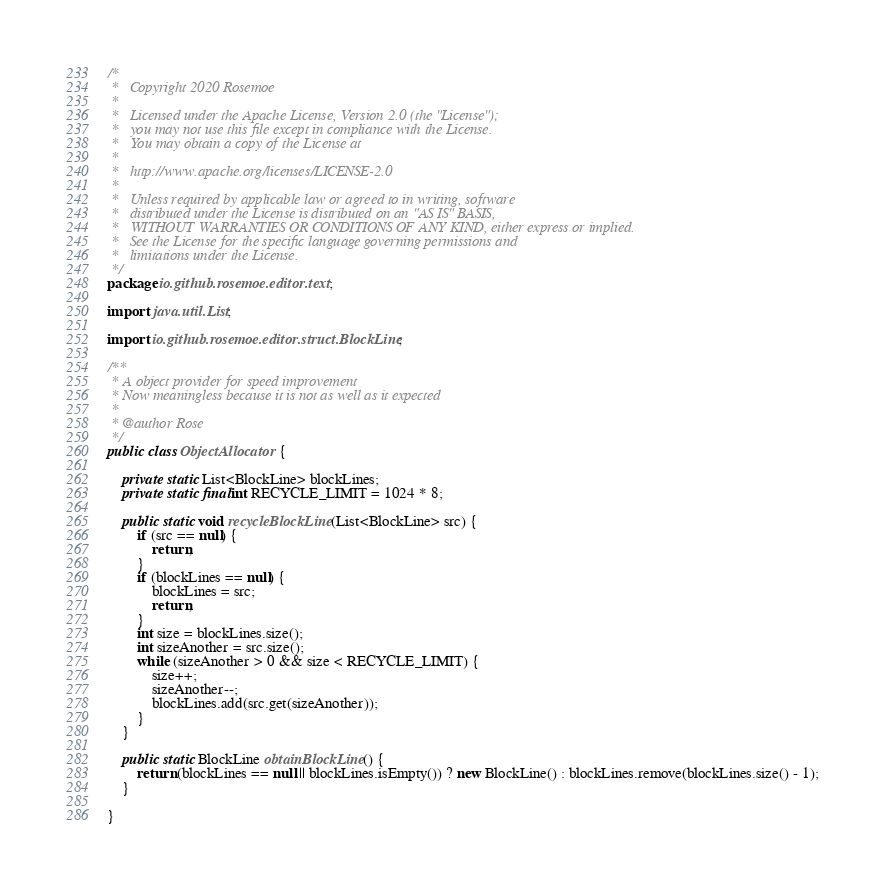<code> <loc_0><loc_0><loc_500><loc_500><_Java_>/*
 *   Copyright 2020 Rosemoe
 *
 *   Licensed under the Apache License, Version 2.0 (the "License");
 *   you may not use this file except in compliance with the License.
 *   You may obtain a copy of the License at
 *
 *   http://www.apache.org/licenses/LICENSE-2.0
 *
 *   Unless required by applicable law or agreed to in writing, software
 *   distributed under the License is distributed on an "AS IS" BASIS,
 *   WITHOUT WARRANTIES OR CONDITIONS OF ANY KIND, either express or implied.
 *   See the License for the specific language governing permissions and
 *   limitations under the License.
 */
package io.github.rosemoe.editor.text;

import java.util.List;

import io.github.rosemoe.editor.struct.BlockLine;

/**
 * A object provider for speed improvement
 * Now meaningless because it is not as well as it expected
 *
 * @author Rose
 */
public class ObjectAllocator {

    private static List<BlockLine> blockLines;
    private static final int RECYCLE_LIMIT = 1024 * 8;

    public static void recycleBlockLine(List<BlockLine> src) {
        if (src == null) {
            return;
        }
        if (blockLines == null) {
            blockLines = src;
            return;
        }
        int size = blockLines.size();
        int sizeAnother = src.size();
        while (sizeAnother > 0 && size < RECYCLE_LIMIT) {
            size++;
            sizeAnother--;
            blockLines.add(src.get(sizeAnother));
        }
    }

    public static BlockLine obtainBlockLine() {
        return (blockLines == null || blockLines.isEmpty()) ? new BlockLine() : blockLines.remove(blockLines.size() - 1);
    }

}
</code> 